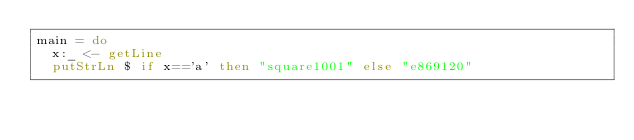<code> <loc_0><loc_0><loc_500><loc_500><_Haskell_>main = do
  x:_ <- getLine
  putStrLn $ if x=='a' then "square1001" else "e869120"
</code> 